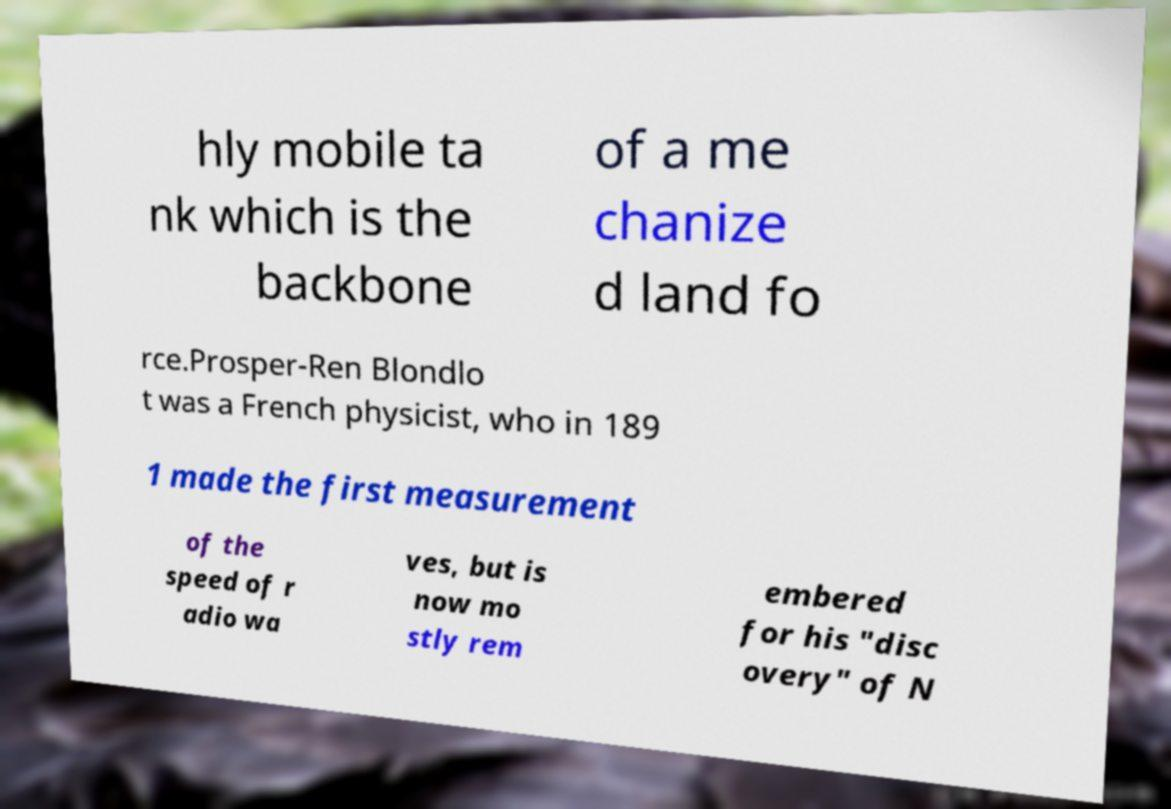There's text embedded in this image that I need extracted. Can you transcribe it verbatim? hly mobile ta nk which is the backbone of a me chanize d land fo rce.Prosper-Ren Blondlo t was a French physicist, who in 189 1 made the first measurement of the speed of r adio wa ves, but is now mo stly rem embered for his "disc overy" of N 